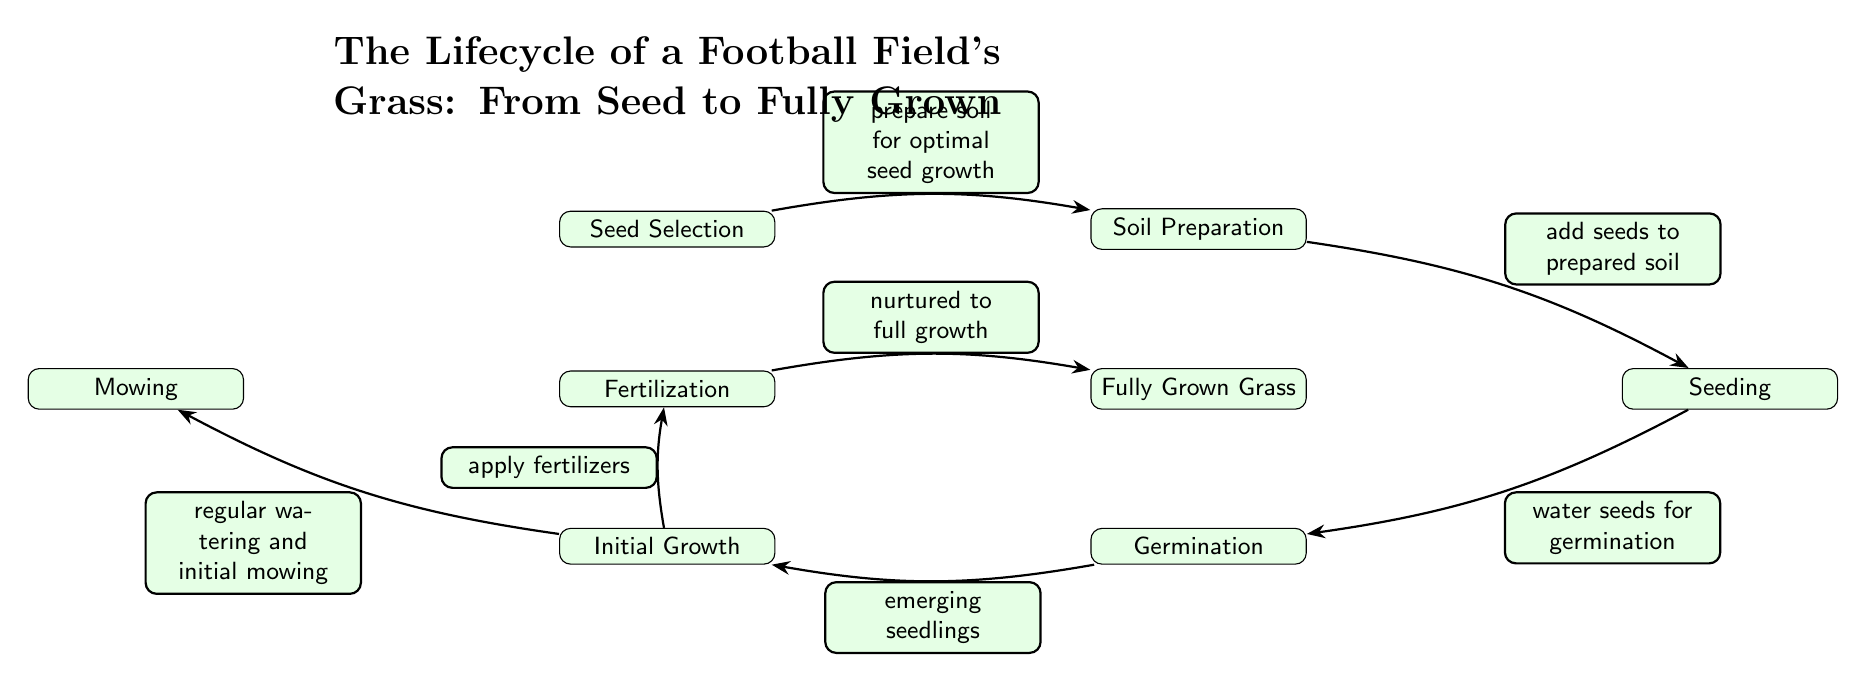What is the first step in the lifecycle of the football field's grass? The first step in the lifecycle, as indicated by the diagram, is "Seed Selection". This is the initial node at the top left that sets the stage for the following processes.
Answer: Seed Selection How many nodes are in the diagram? By counting all the individual steps (nodes) depicted in the diagram, we can see that there are a total of 7 nodes: Seed Selection, Soil Preparation, Seeding, Germination, Initial Growth, Mowing, Fertilization, and Fully Grown Grass.
Answer: 7 What comes after "Seeding"? Looking at the diagram, directly after the "Seeding" node in the flow is the "Germination" node, which follows the seeding process according to the indicated order of operations.
Answer: Germination Which process involves applying fertilizers? From the diagram, the process of applying fertilizers is indicated as a direct outcome of the "Initial Growth" node, leading to the "Fully Grown Grass" node.
Answer: Fertilization What is the relationship between "Initial Growth" and "Mowing"? The diagram shows that there is a direct connection from the "Initial Growth" node to the "Mowing" node, meaning that mowing is a part of the care required during the initial growth phase.
Answer: Regular watering and initial mowing What are the two actions performed during "Initial Growth"? The diagram indicates two actions associated with "Initial Growth": "regular watering" and "apply fertilizers". To deduce this, we can refer to the connections emerging from the "Initial Growth" node.
Answer: Regular watering and apply fertilizers What is the end result of the entire lifecycle process? The diagram clearly indicates that the end result of the lifecycle is "Fully Grown Grass", explicitly noted as the last node in the flow.
Answer: Fully Grown Grass How does "Soil Preparation" relate to "Seed Selection"? The diagram illustrates that "Soil Preparation" follows directly after "Seed Selection", marking the progression from choosing the seeds to preparing the soil for planting them.
Answer: Prepare soil for optimal seed growth What action follows "Fertilization"? According to the diagram, the action that follows "Fertilization" is "Fully Grown Grass". This suggests that fertilization is a crucial step in nurturing the grass toward its final growth stage.
Answer: Nurtured to full growth 